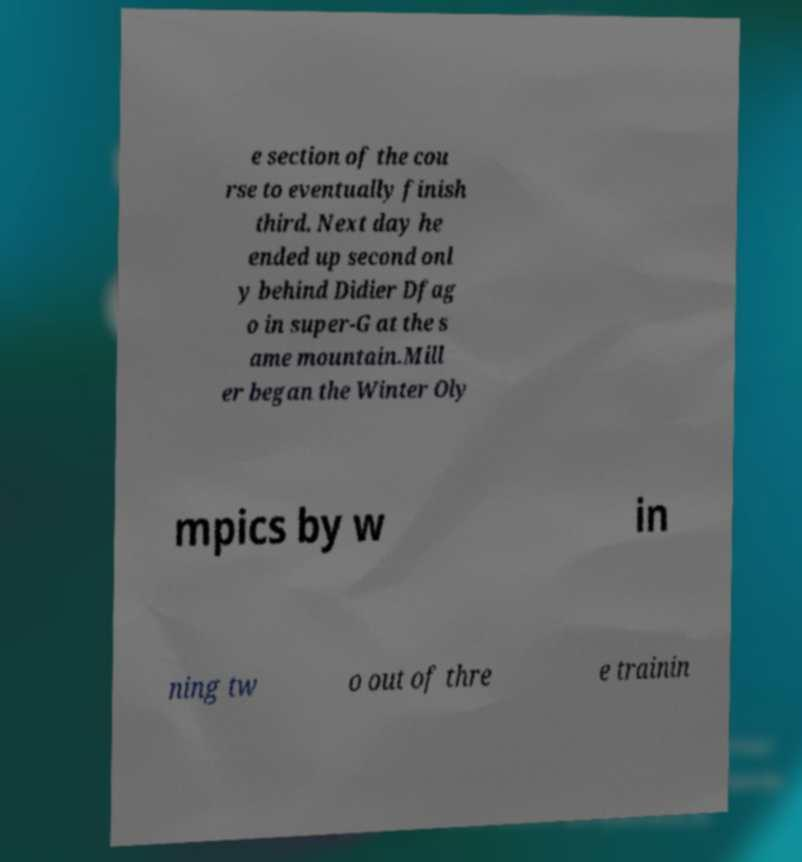Can you read and provide the text displayed in the image?This photo seems to have some interesting text. Can you extract and type it out for me? e section of the cou rse to eventually finish third. Next day he ended up second onl y behind Didier Dfag o in super-G at the s ame mountain.Mill er began the Winter Oly mpics by w in ning tw o out of thre e trainin 